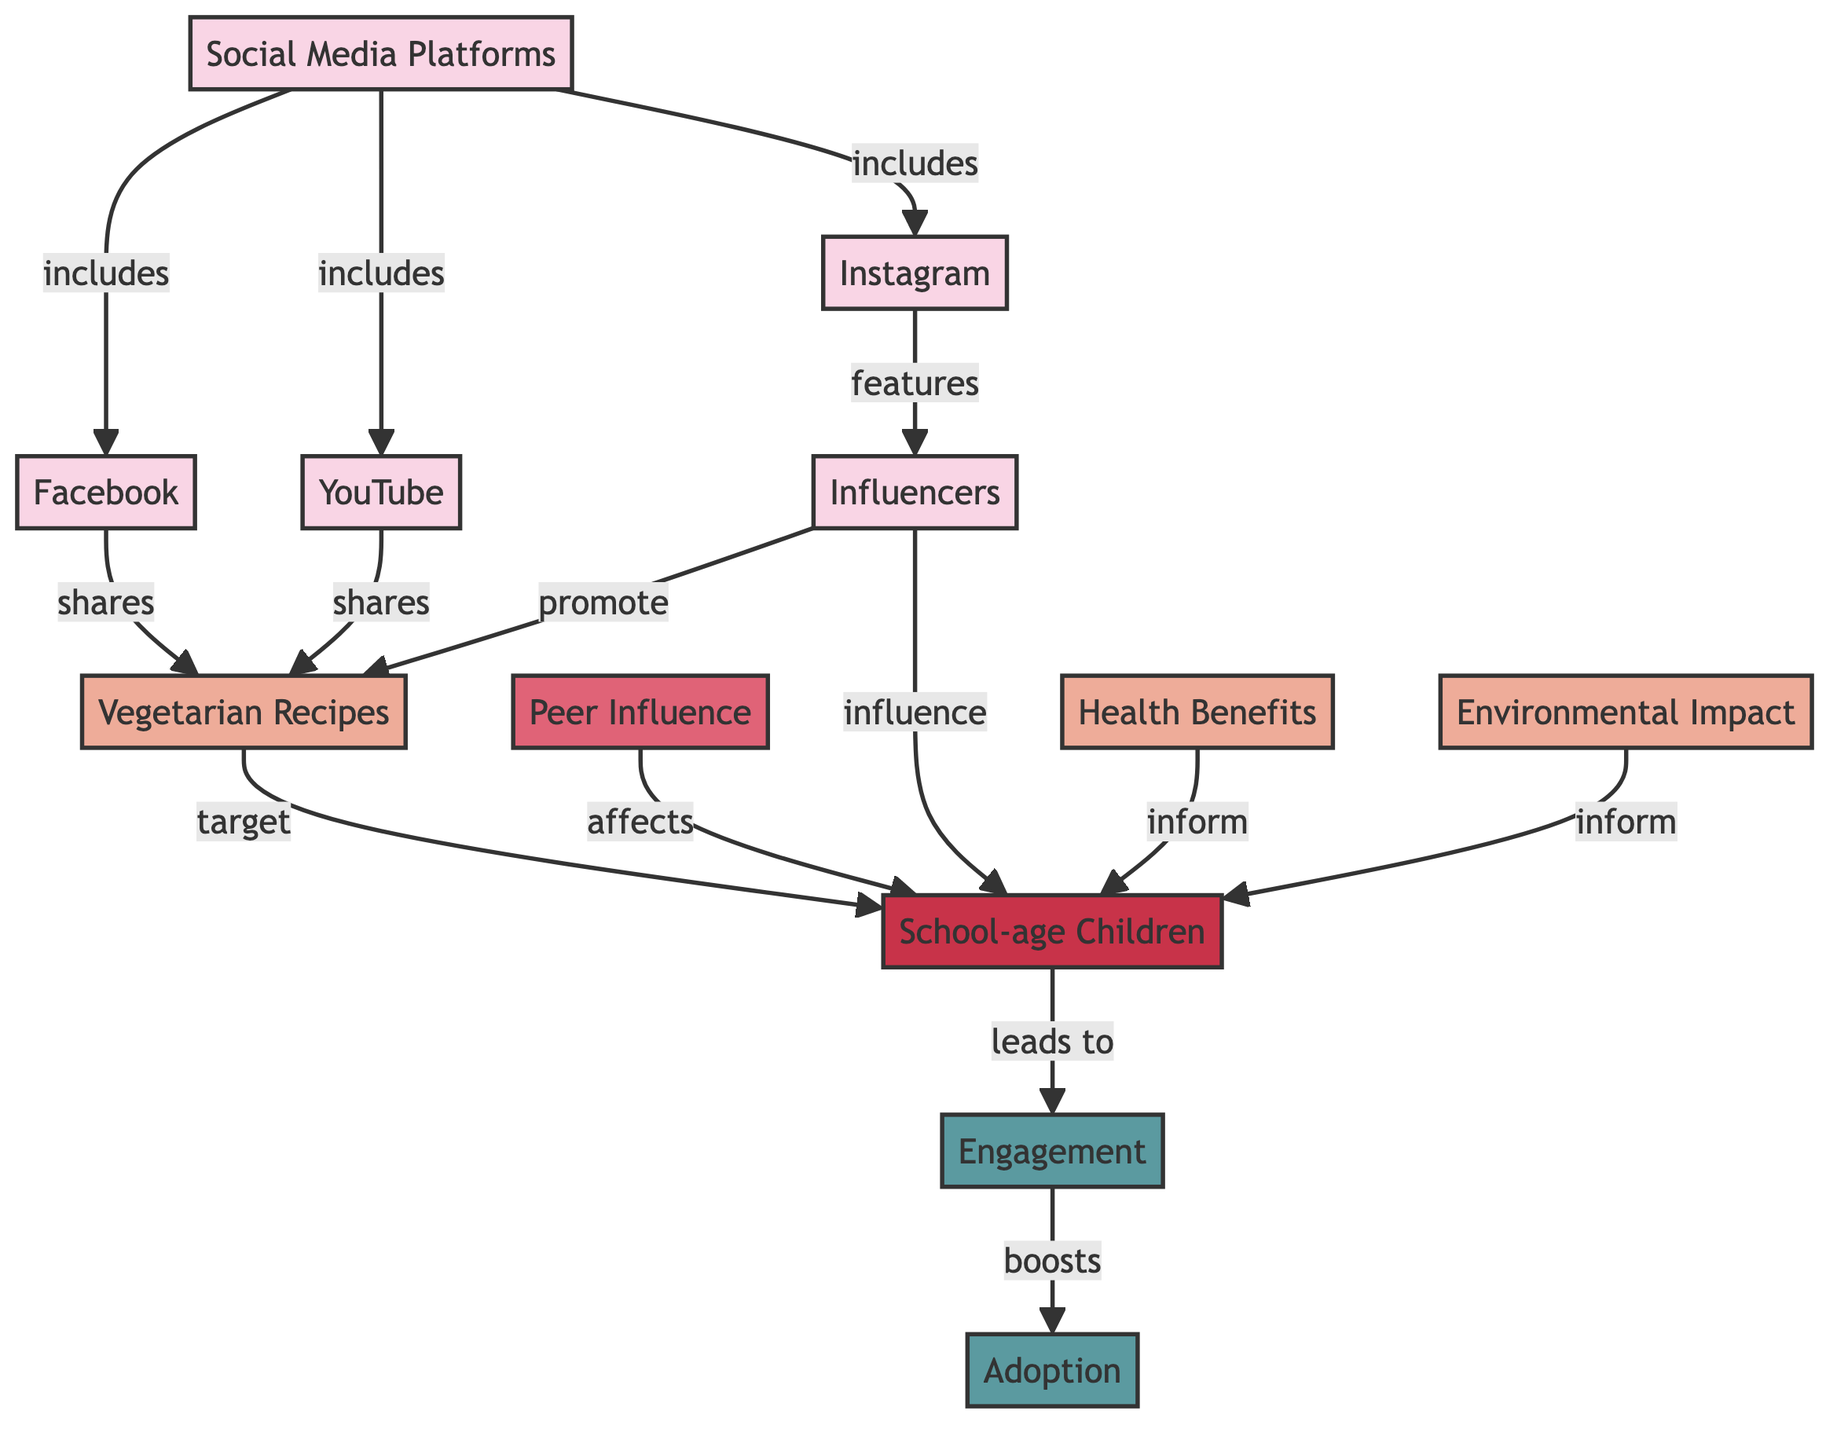What are the three social media platforms listed in the diagram? The diagram includes the nodes for Facebook, Instagram, and YouTube under the "Social Media Platforms" node. These are directly connected to it, making them the three platforms.
Answer: Facebook, Instagram, YouTube How many types of content are presented in the diagram? The diagram shows three distinct content types: Vegetarian Recipes, Health Benefits, and Environmental Impact. Each type is represented as a separate node in the flowchart.
Answer: 3 What influences school-age children's adoption of vegetarian lifestyles according to the diagram? The diagram indicates that both peer influence and influencers have a direct impact on school-age children, as they are connected to the "School-age Children" node.
Answer: Peer Influence and Influencers What is the relationship between vegetarian recipes and school-age children? The diagram illustrates that vegetarian recipes are shared and targeted towards school-age children, suggesting a direct connection in promoting vegetarian lifestyles among them.
Answer: Targeted Which outcome is directly boosted by engagement according to the diagram? The diagram specifies that the outcome of "Adoption" is influenced by "Engagement," indicating a direct boost from one to the other as a result.
Answer: Adoption How are influencers connected to vegetarian recipes in the flowchart? The flowchart shows a direct arrow from influencers to vegetarian recipes, indicating they actively promote these recipes, connecting the two concepts.
Answer: Promote Which factor affects the school-age children besides the influencers? According to the diagram, peer influence also affects school-age children, indicating multiple sources influencing their lifestyle choices.
Answer: Peer Influence 